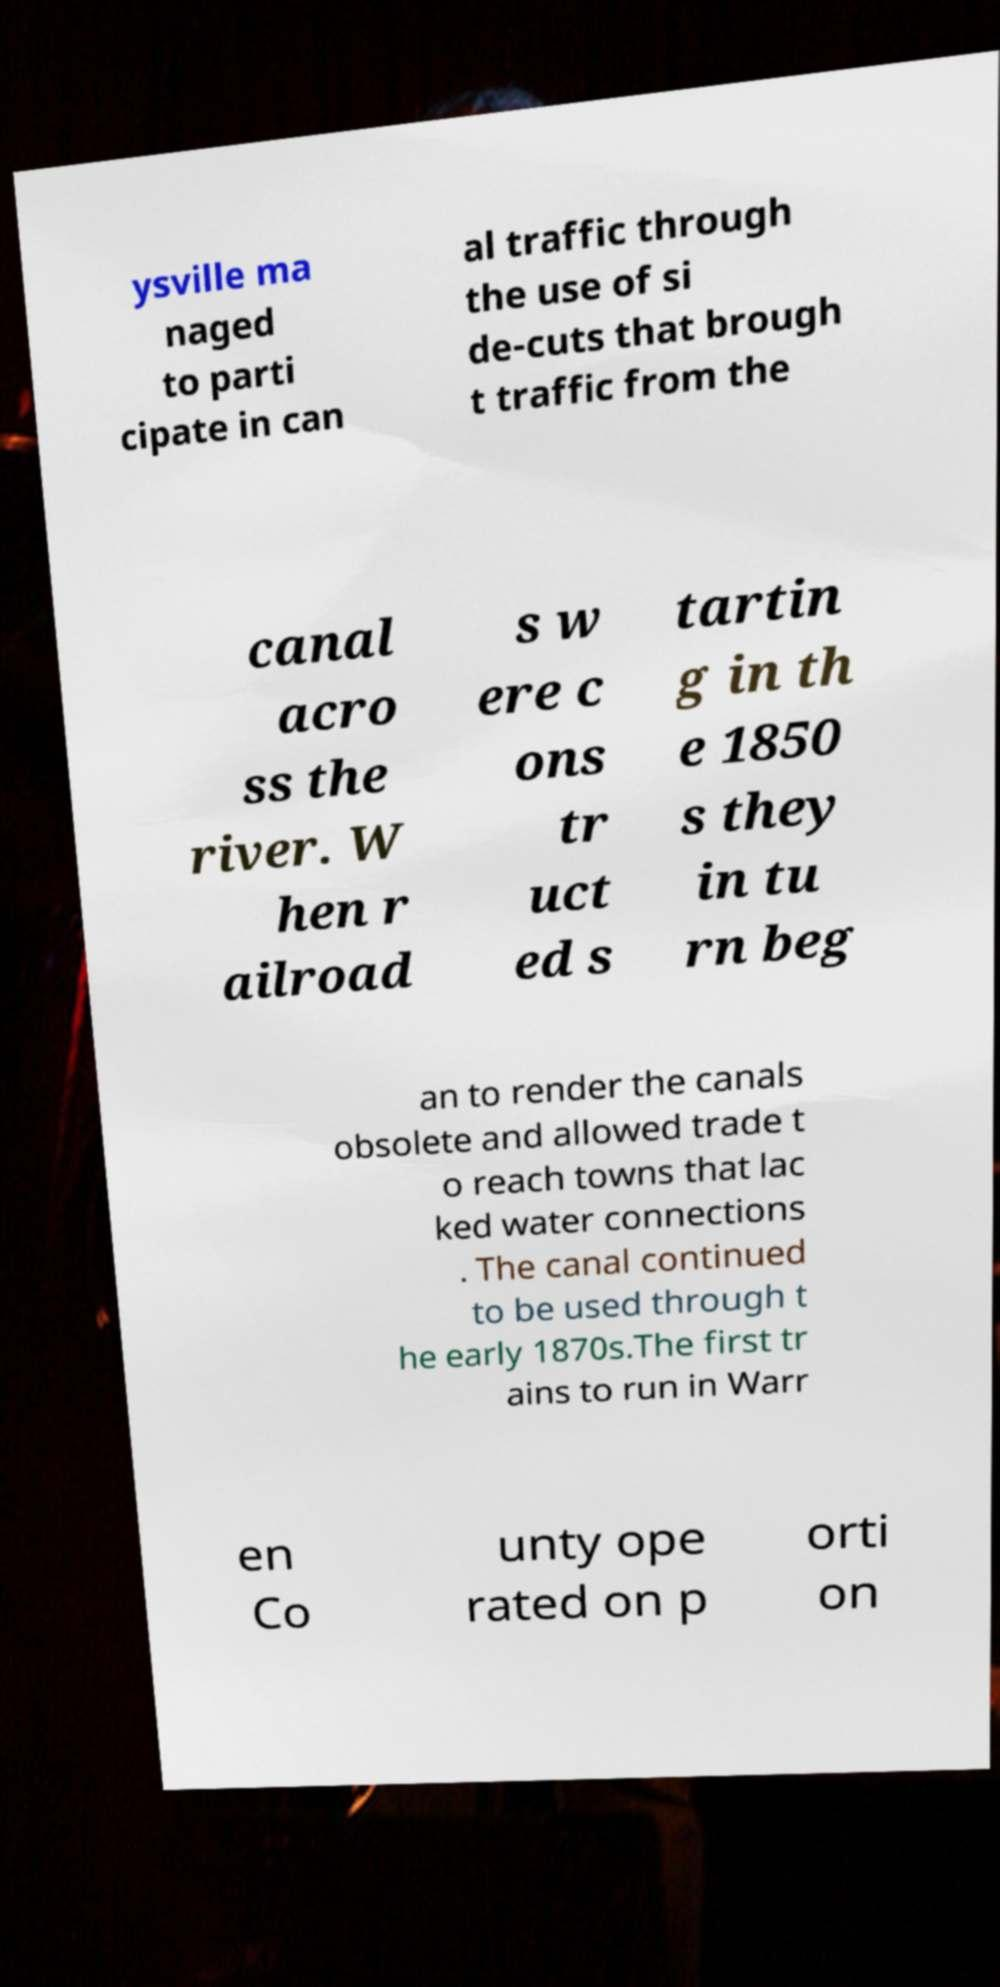I need the written content from this picture converted into text. Can you do that? ysville ma naged to parti cipate in can al traffic through the use of si de-cuts that brough t traffic from the canal acro ss the river. W hen r ailroad s w ere c ons tr uct ed s tartin g in th e 1850 s they in tu rn beg an to render the canals obsolete and allowed trade t o reach towns that lac ked water connections . The canal continued to be used through t he early 1870s.The first tr ains to run in Warr en Co unty ope rated on p orti on 